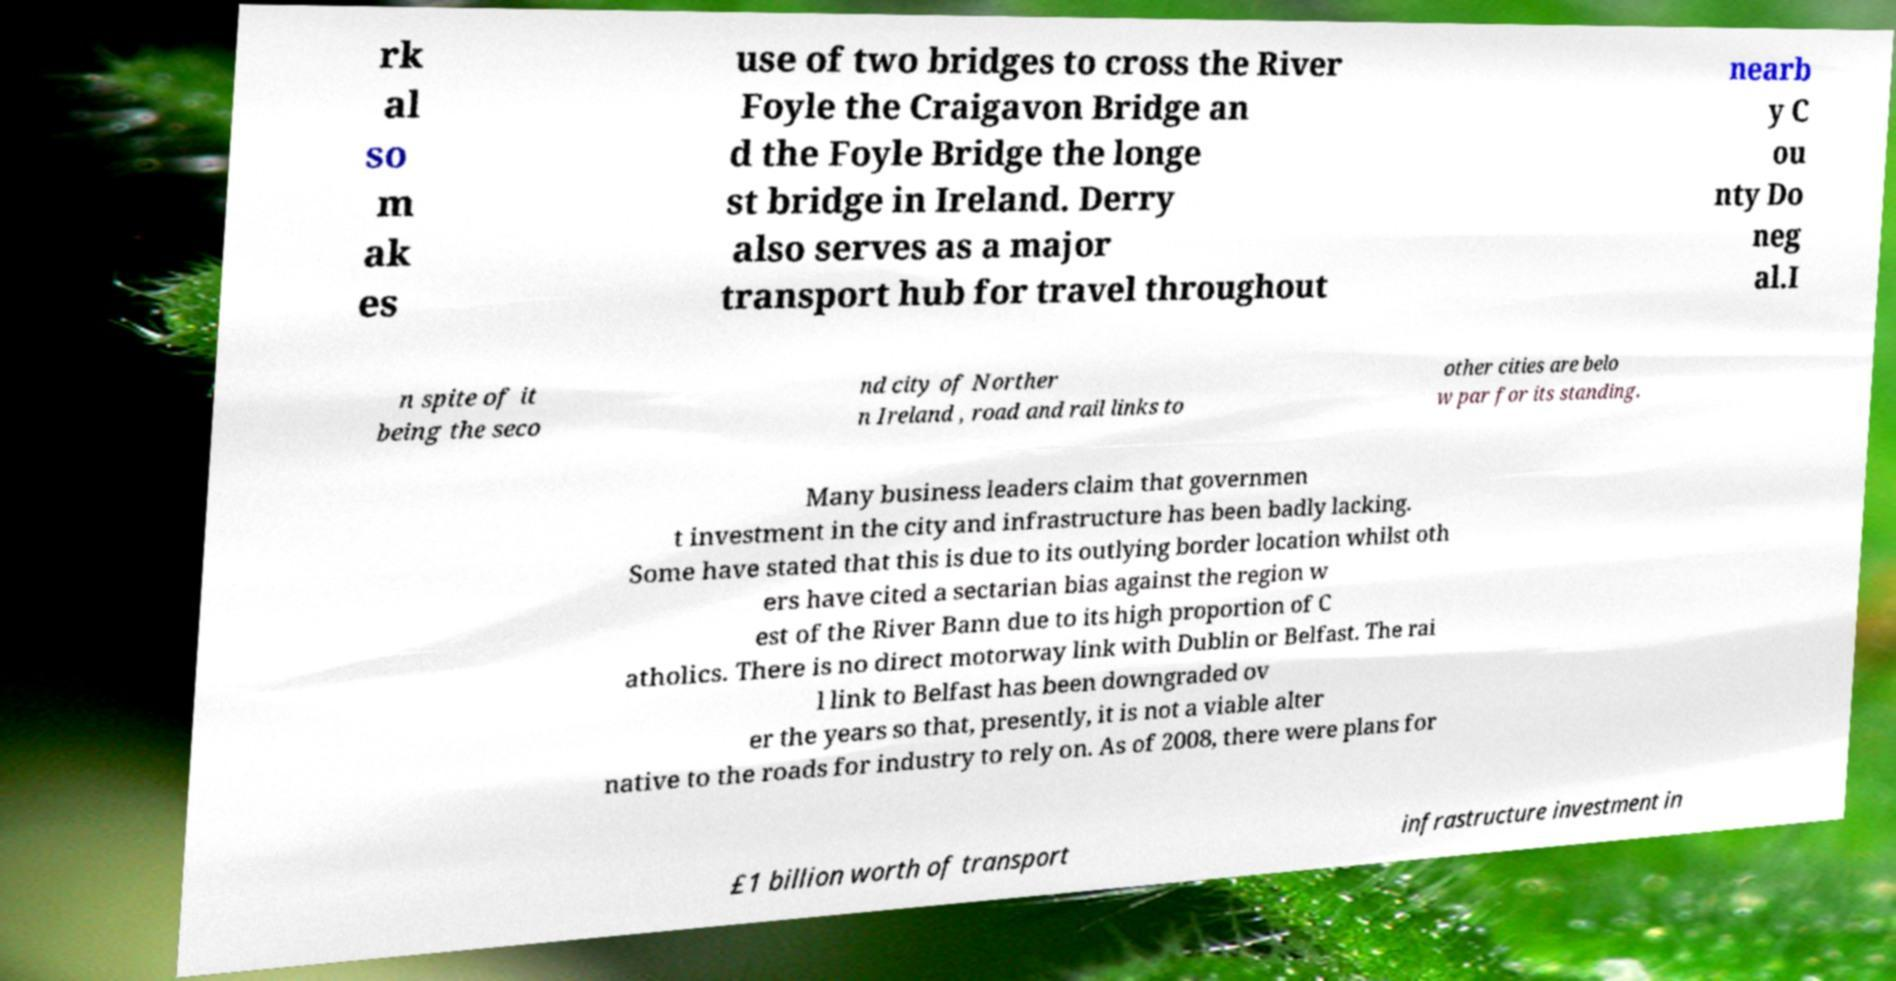Could you assist in decoding the text presented in this image and type it out clearly? rk al so m ak es use of two bridges to cross the River Foyle the Craigavon Bridge an d the Foyle Bridge the longe st bridge in Ireland. Derry also serves as a major transport hub for travel throughout nearb y C ou nty Do neg al.I n spite of it being the seco nd city of Norther n Ireland , road and rail links to other cities are belo w par for its standing. Many business leaders claim that governmen t investment in the city and infrastructure has been badly lacking. Some have stated that this is due to its outlying border location whilst oth ers have cited a sectarian bias against the region w est of the River Bann due to its high proportion of C atholics. There is no direct motorway link with Dublin or Belfast. The rai l link to Belfast has been downgraded ov er the years so that, presently, it is not a viable alter native to the roads for industry to rely on. As of 2008, there were plans for £1 billion worth of transport infrastructure investment in 